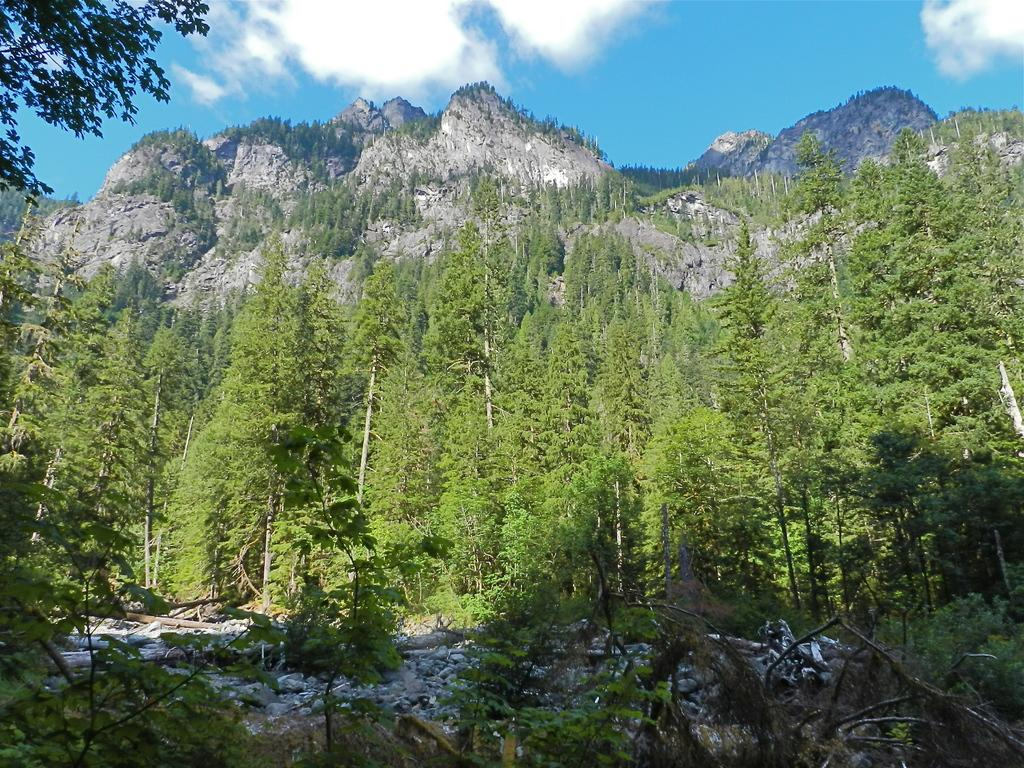What type of landscape is depicted in the image? The image features hills and trees. Are there any specific features at the bottom of the image? Yes, there are rocks at the bottom of the image. What can be seen in the sky at the top of the image? There are clouds in the sky at the top of the image. How does the pot move around in the image? There is no pot present in the image, so it cannot move around. What type of rock is shown interacting with the trees in the image? There are no rocks interacting with the trees in the image; the rocks are at the bottom of the image, separate from the trees. 